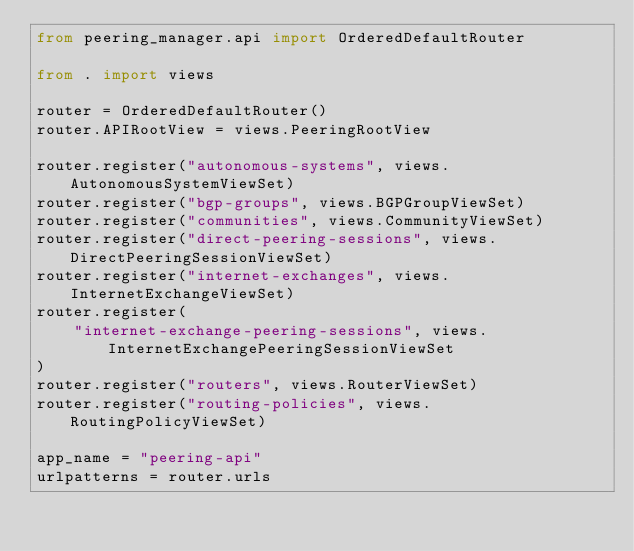Convert code to text. <code><loc_0><loc_0><loc_500><loc_500><_Python_>from peering_manager.api import OrderedDefaultRouter

from . import views

router = OrderedDefaultRouter()
router.APIRootView = views.PeeringRootView

router.register("autonomous-systems", views.AutonomousSystemViewSet)
router.register("bgp-groups", views.BGPGroupViewSet)
router.register("communities", views.CommunityViewSet)
router.register("direct-peering-sessions", views.DirectPeeringSessionViewSet)
router.register("internet-exchanges", views.InternetExchangeViewSet)
router.register(
    "internet-exchange-peering-sessions", views.InternetExchangePeeringSessionViewSet
)
router.register("routers", views.RouterViewSet)
router.register("routing-policies", views.RoutingPolicyViewSet)

app_name = "peering-api"
urlpatterns = router.urls
</code> 